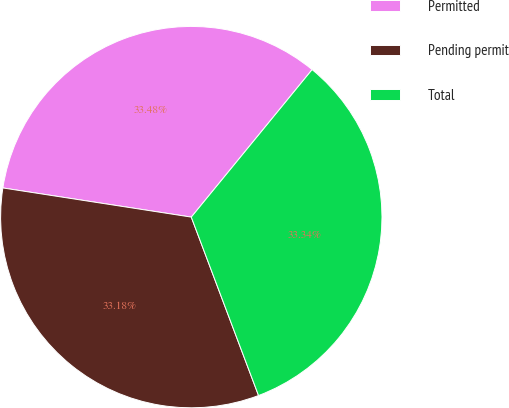Convert chart to OTSL. <chart><loc_0><loc_0><loc_500><loc_500><pie_chart><fcel>Permitted<fcel>Pending permit<fcel>Total<nl><fcel>33.48%<fcel>33.18%<fcel>33.34%<nl></chart> 